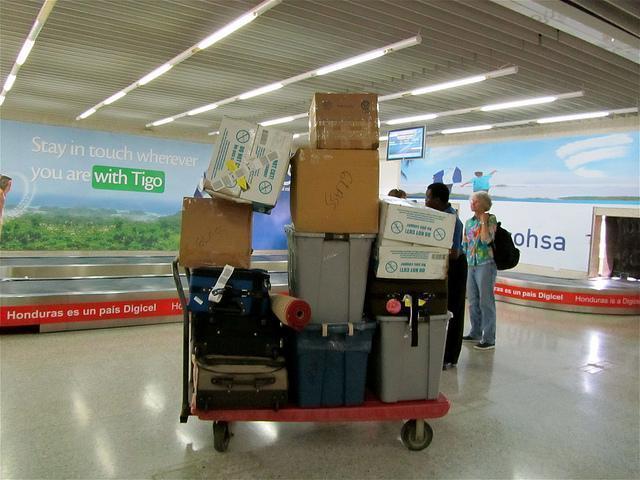What country is this venue situated in?
Select the correct answer and articulate reasoning with the following format: 'Answer: answer
Rationale: rationale.'
Options: Spain, honduras, chile, mexico. Answer: honduras.
Rationale: The venue's text indicates honduras. 